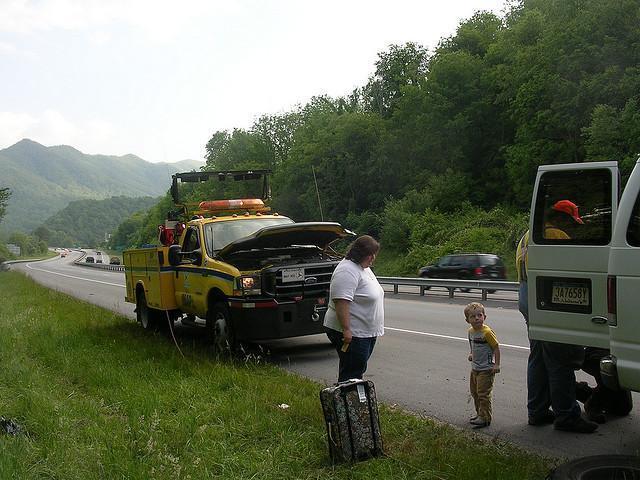How many people are there?
Give a very brief answer. 3. How many suitcases are there?
Give a very brief answer. 1. How many trucks are there?
Give a very brief answer. 2. How many bears are there?
Give a very brief answer. 0. 